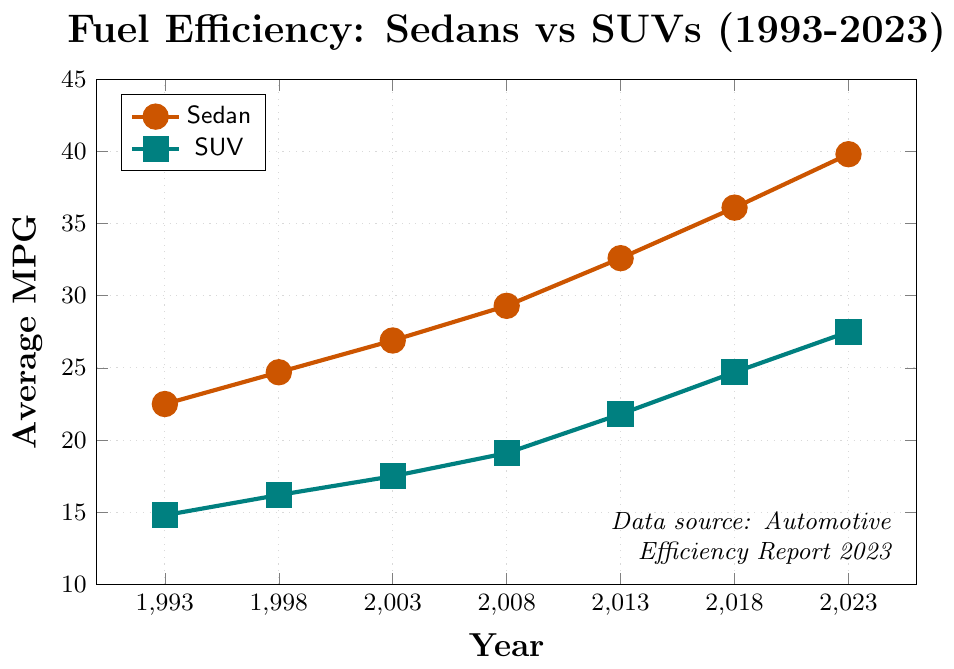What was the average MPG improvement for sedans from 1993 to 2023? First, look at the MPG values for sedans in 1993 and 2023. Subtract the 1993 value from the 2023 value: 39.8 - 22.5 = 17.3.
Answer: 17.3 By how much did the average MPG for SUVs increase from 1998 to 2018? Find the MPG values for SUVs in 1998 and 2018. Subtract the 1998 value from the 2018 value: 24.7 - 16.2 = 8.5.
Answer: 8.5 Which type of vehicle had a higher average MPG improvement over the 30 years, sedans or SUVs? Calculate the improvements for both: Sedans from 22.5 to 39.8 (39.8 - 22.5 = 17.3) and SUVs from 14.8 to 27.5 (27.5 - 14.8 = 12.7). Compare the two values: 17.3 (sedans) vs. 12.7 (SUVs).
Answer: Sedans In which year did sedans have an average MPG that first exceeded 30? Check the MPG values for sedans across the years to find when it first surpasses 30. In 2013, the average MPG for sedans was 32.6, the first year above 30 MPG.
Answer: 2013 What is the average MPG of SUVs in 2008? Look at the figure to find the MPG value for SUVs in the year 2008. It's 19.1.
Answer: 19.1 By how much did the average MPG of sedans increase between 2003 and 2023? Look at the MPG for sedans in 2003 and 2023. Subtract the 2003 value from the 2023 value: 39.8 - 26.9 = 12.9.
Answer: 12.9 How much higher is the MPG of sedans compared to SUVs in 2023? Identify the MPG values for both sedans and SUVs in 2023, and then subtract the SUV value from the sedan value: 39.8 - 27.5 = 12.3.
Answer: 12.3 Which vehicle type had a higher average MPG in 2013, and by how much? Check the MPG values for sedans and SUVs in 2013. Sedans had 32.6 MPG, and SUVs had 21.8 MPG. Subtract the SUV value from the sedan value: 32.6 - 21.8 = 10.8.
Answer: Sedans by 10.8 What was the rate of average MPG improvement for sedans per year from 2008 to 2018? Calculate the difference in MPG for sedans between 2008 and 2018: 36.1 - 29.3 = 6.8. Then divide by the number of years (2018-2008): 6.8 / 10 = 0.68 MPG per year.
Answer: 0.68 Which vehicle type showed a higher increase in average MPG between 2003 and 2008, and by how much? Find the difference in MPG for both vehicles between 2003 and 2008: Sedans: 29.3 - 26.9 = 2.4. SUVs: 19.1 - 17.5 = 1.6. Compare the increases: 2.4 (sedans) - 1.6 (SUVs) = 0.8.
Answer: Sedans by 0.8 